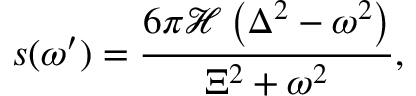Convert formula to latex. <formula><loc_0><loc_0><loc_500><loc_500>s ( \omega ^ { \prime } ) = \frac { 6 \pi \mathcal { H } \left ( \Delta ^ { 2 } - \omega ^ { 2 } \right ) } { \Xi ^ { 2 } + \omega ^ { 2 } } ,</formula> 